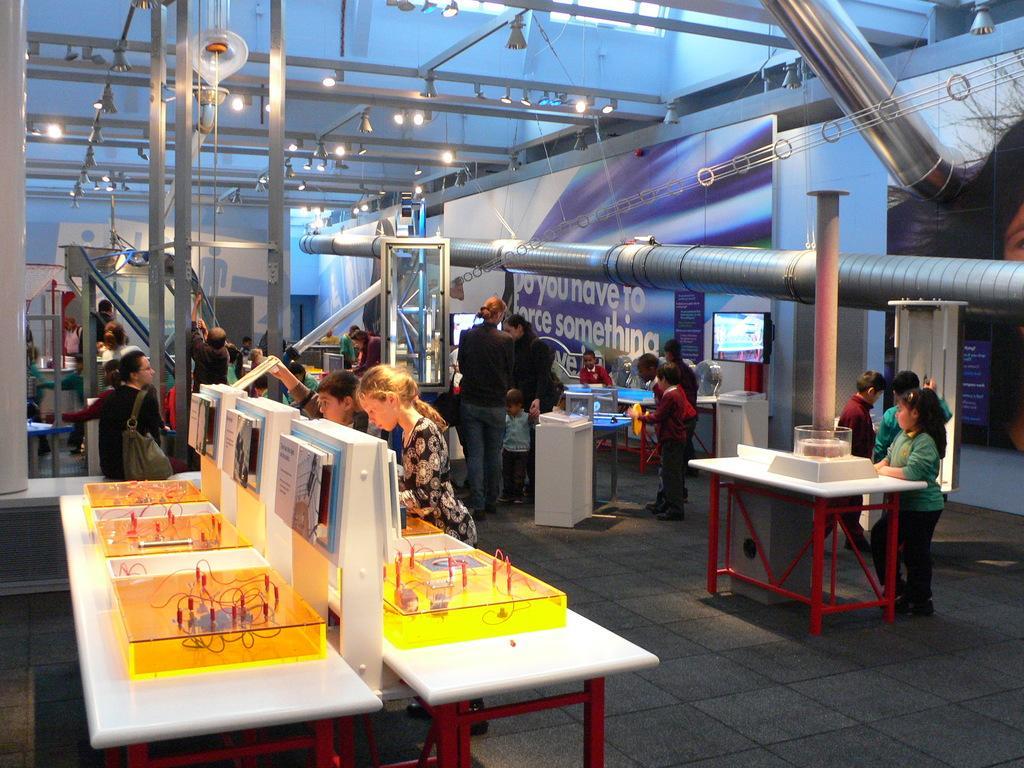How would you summarize this image in a sentence or two? There are so many people standing in a room operating an electrical boards. 